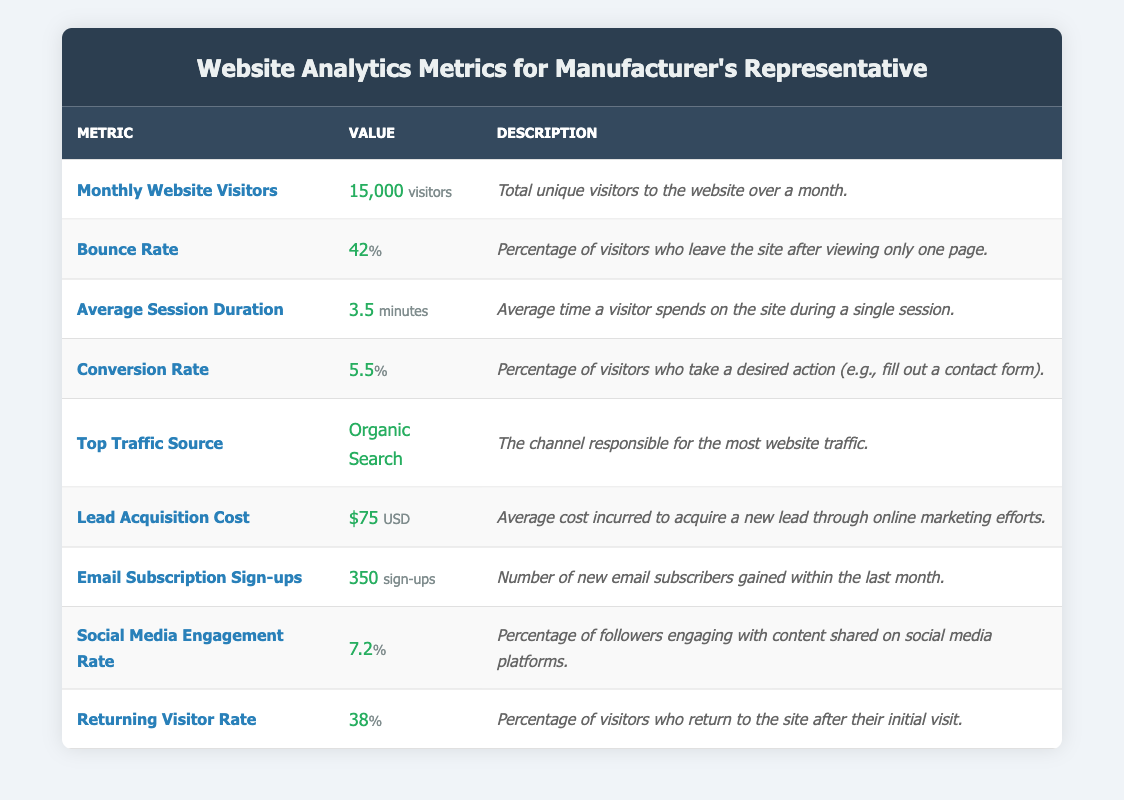What is the Monthly Website Visitors count? The table clearly states that the "Monthly Website Visitors" metric has a value of 15,000 visitors.
Answer: 15,000 What is the Bounce Rate percentage? The table shows that the "Bounce Rate" metric is 42 percent.
Answer: 42 percent Is the Average Session Duration greater than 5 minutes? The table indicates that the "Average Session Duration" is 3.5 minutes, which is less than 5 minutes.
Answer: No What is the difference between the Social Media Engagement Rate and the Conversion Rate? The table lists the "Social Media Engagement Rate" as 7.2 percent and the "Conversion Rate" as 5.5 percent. The difference is calculated as 7.2 minus 5.5, which equals 1.7 percent.
Answer: 1.7 percent What percentage of visitors return to the site after their initial visit? The "Returning Visitor Rate" is specified in the table as 38 percent.
Answer: 38 percent If the Lead Acquisition Cost increases by 15 USD, what will be the new cost? The current "Lead Acquisition Cost" is 75 USD. If we add 15 USD to this amount (75 + 15), the new Lead Acquisition Cost will be 90 USD.
Answer: 90 USD What is the total number of Email Subscription Sign-ups and Monthly Website Visitors? The table provides "Email Subscription Sign-ups" as 350 and "Monthly Website Visitors" as 15,000. By adding these two values (15,000 + 350), the total is 15,350.
Answer: 15,350 Is the Top Traffic Source listed as "Direct Traffic"? The table indicates the "Top Traffic Source" is "Organic Search", not "Direct Traffic", so the statement is false.
Answer: No What is the average of the Bounce Rate and Returning Visitor Rate? The "Bounce Rate" is 42 percent and the "Returning Visitor Rate" is 38 percent. To find the average, we add these percentages (42 + 38) to get 80, then divide by 2, which results in an average of 40 percent.
Answer: 40 percent 